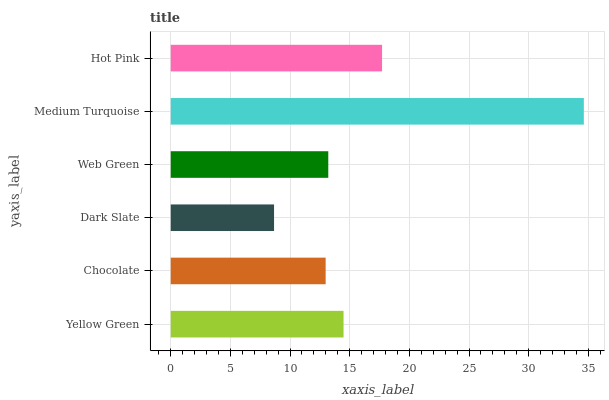Is Dark Slate the minimum?
Answer yes or no. Yes. Is Medium Turquoise the maximum?
Answer yes or no. Yes. Is Chocolate the minimum?
Answer yes or no. No. Is Chocolate the maximum?
Answer yes or no. No. Is Yellow Green greater than Chocolate?
Answer yes or no. Yes. Is Chocolate less than Yellow Green?
Answer yes or no. Yes. Is Chocolate greater than Yellow Green?
Answer yes or no. No. Is Yellow Green less than Chocolate?
Answer yes or no. No. Is Yellow Green the high median?
Answer yes or no. Yes. Is Web Green the low median?
Answer yes or no. Yes. Is Chocolate the high median?
Answer yes or no. No. Is Dark Slate the low median?
Answer yes or no. No. 